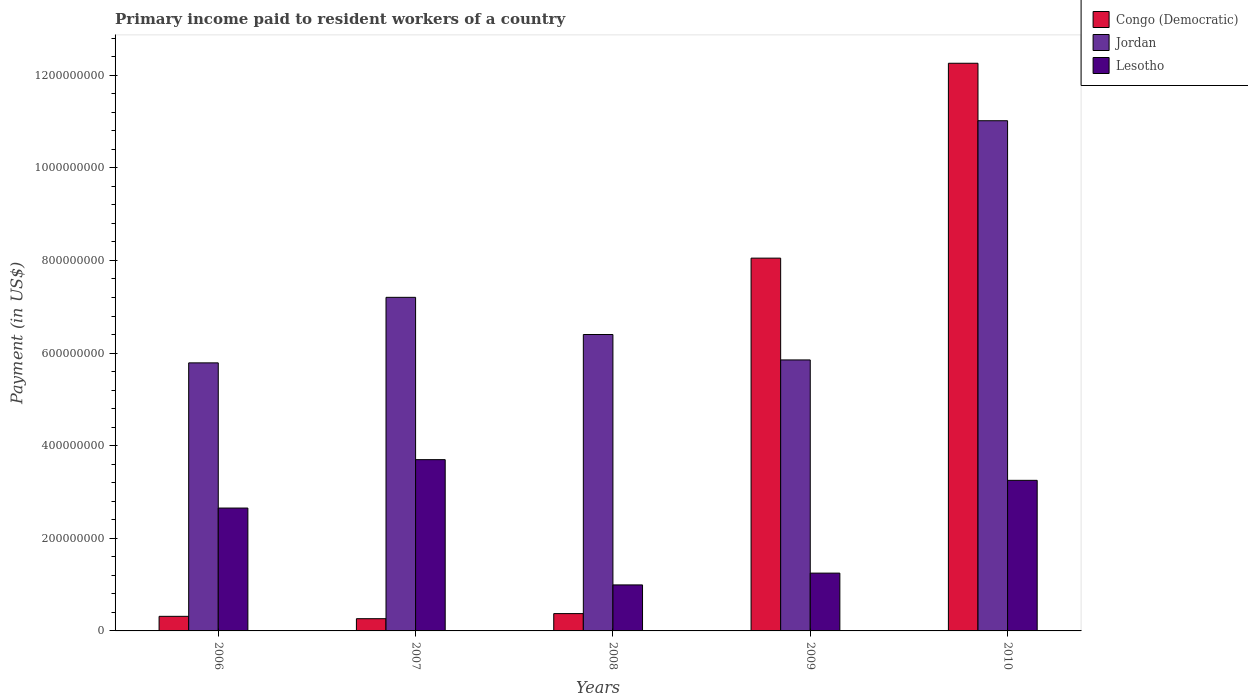How many groups of bars are there?
Your response must be concise. 5. Are the number of bars per tick equal to the number of legend labels?
Your response must be concise. Yes. Are the number of bars on each tick of the X-axis equal?
Provide a short and direct response. Yes. In how many cases, is the number of bars for a given year not equal to the number of legend labels?
Your answer should be very brief. 0. What is the amount paid to workers in Congo (Democratic) in 2007?
Offer a terse response. 2.64e+07. Across all years, what is the maximum amount paid to workers in Jordan?
Provide a succinct answer. 1.10e+09. Across all years, what is the minimum amount paid to workers in Jordan?
Ensure brevity in your answer.  5.79e+08. In which year was the amount paid to workers in Congo (Democratic) minimum?
Offer a very short reply. 2007. What is the total amount paid to workers in Congo (Democratic) in the graph?
Make the answer very short. 2.13e+09. What is the difference between the amount paid to workers in Jordan in 2008 and that in 2010?
Provide a short and direct response. -4.62e+08. What is the difference between the amount paid to workers in Lesotho in 2010 and the amount paid to workers in Jordan in 2006?
Your response must be concise. -2.54e+08. What is the average amount paid to workers in Lesotho per year?
Provide a succinct answer. 2.37e+08. In the year 2010, what is the difference between the amount paid to workers in Jordan and amount paid to workers in Congo (Democratic)?
Make the answer very short. -1.24e+08. In how many years, is the amount paid to workers in Jordan greater than 240000000 US$?
Give a very brief answer. 5. What is the ratio of the amount paid to workers in Jordan in 2007 to that in 2010?
Keep it short and to the point. 0.65. What is the difference between the highest and the second highest amount paid to workers in Congo (Democratic)?
Provide a short and direct response. 4.21e+08. What is the difference between the highest and the lowest amount paid to workers in Congo (Democratic)?
Provide a short and direct response. 1.20e+09. In how many years, is the amount paid to workers in Congo (Democratic) greater than the average amount paid to workers in Congo (Democratic) taken over all years?
Provide a short and direct response. 2. Is the sum of the amount paid to workers in Congo (Democratic) in 2006 and 2009 greater than the maximum amount paid to workers in Lesotho across all years?
Make the answer very short. Yes. What does the 1st bar from the left in 2009 represents?
Make the answer very short. Congo (Democratic). What does the 1st bar from the right in 2007 represents?
Your answer should be compact. Lesotho. Is it the case that in every year, the sum of the amount paid to workers in Congo (Democratic) and amount paid to workers in Lesotho is greater than the amount paid to workers in Jordan?
Ensure brevity in your answer.  No. How many bars are there?
Ensure brevity in your answer.  15. How many years are there in the graph?
Provide a succinct answer. 5. Does the graph contain any zero values?
Make the answer very short. No. Where does the legend appear in the graph?
Make the answer very short. Top right. What is the title of the graph?
Your answer should be compact. Primary income paid to resident workers of a country. Does "El Salvador" appear as one of the legend labels in the graph?
Give a very brief answer. No. What is the label or title of the Y-axis?
Your answer should be very brief. Payment (in US$). What is the Payment (in US$) in Congo (Democratic) in 2006?
Make the answer very short. 3.15e+07. What is the Payment (in US$) in Jordan in 2006?
Offer a very short reply. 5.79e+08. What is the Payment (in US$) in Lesotho in 2006?
Provide a short and direct response. 2.65e+08. What is the Payment (in US$) in Congo (Democratic) in 2007?
Provide a short and direct response. 2.64e+07. What is the Payment (in US$) of Jordan in 2007?
Your response must be concise. 7.20e+08. What is the Payment (in US$) in Lesotho in 2007?
Offer a terse response. 3.70e+08. What is the Payment (in US$) in Congo (Democratic) in 2008?
Make the answer very short. 3.74e+07. What is the Payment (in US$) of Jordan in 2008?
Give a very brief answer. 6.40e+08. What is the Payment (in US$) of Lesotho in 2008?
Offer a very short reply. 9.93e+07. What is the Payment (in US$) of Congo (Democratic) in 2009?
Your answer should be very brief. 8.05e+08. What is the Payment (in US$) of Jordan in 2009?
Make the answer very short. 5.85e+08. What is the Payment (in US$) of Lesotho in 2009?
Provide a short and direct response. 1.25e+08. What is the Payment (in US$) in Congo (Democratic) in 2010?
Your answer should be very brief. 1.23e+09. What is the Payment (in US$) of Jordan in 2010?
Offer a very short reply. 1.10e+09. What is the Payment (in US$) of Lesotho in 2010?
Offer a terse response. 3.25e+08. Across all years, what is the maximum Payment (in US$) in Congo (Democratic)?
Your answer should be very brief. 1.23e+09. Across all years, what is the maximum Payment (in US$) of Jordan?
Give a very brief answer. 1.10e+09. Across all years, what is the maximum Payment (in US$) of Lesotho?
Keep it short and to the point. 3.70e+08. Across all years, what is the minimum Payment (in US$) in Congo (Democratic)?
Provide a succinct answer. 2.64e+07. Across all years, what is the minimum Payment (in US$) in Jordan?
Provide a short and direct response. 5.79e+08. Across all years, what is the minimum Payment (in US$) in Lesotho?
Your answer should be compact. 9.93e+07. What is the total Payment (in US$) of Congo (Democratic) in the graph?
Offer a terse response. 2.13e+09. What is the total Payment (in US$) of Jordan in the graph?
Provide a succinct answer. 3.63e+09. What is the total Payment (in US$) of Lesotho in the graph?
Give a very brief answer. 1.18e+09. What is the difference between the Payment (in US$) of Congo (Democratic) in 2006 and that in 2007?
Offer a terse response. 5.10e+06. What is the difference between the Payment (in US$) of Jordan in 2006 and that in 2007?
Make the answer very short. -1.42e+08. What is the difference between the Payment (in US$) in Lesotho in 2006 and that in 2007?
Offer a terse response. -1.05e+08. What is the difference between the Payment (in US$) of Congo (Democratic) in 2006 and that in 2008?
Offer a terse response. -5.90e+06. What is the difference between the Payment (in US$) in Jordan in 2006 and that in 2008?
Ensure brevity in your answer.  -6.12e+07. What is the difference between the Payment (in US$) in Lesotho in 2006 and that in 2008?
Make the answer very short. 1.66e+08. What is the difference between the Payment (in US$) of Congo (Democratic) in 2006 and that in 2009?
Give a very brief answer. -7.74e+08. What is the difference between the Payment (in US$) of Jordan in 2006 and that in 2009?
Your response must be concise. -6.33e+06. What is the difference between the Payment (in US$) of Lesotho in 2006 and that in 2009?
Offer a very short reply. 1.40e+08. What is the difference between the Payment (in US$) in Congo (Democratic) in 2006 and that in 2010?
Make the answer very short. -1.19e+09. What is the difference between the Payment (in US$) in Jordan in 2006 and that in 2010?
Give a very brief answer. -5.23e+08. What is the difference between the Payment (in US$) in Lesotho in 2006 and that in 2010?
Offer a terse response. -5.99e+07. What is the difference between the Payment (in US$) of Congo (Democratic) in 2007 and that in 2008?
Offer a very short reply. -1.10e+07. What is the difference between the Payment (in US$) in Jordan in 2007 and that in 2008?
Give a very brief answer. 8.03e+07. What is the difference between the Payment (in US$) in Lesotho in 2007 and that in 2008?
Ensure brevity in your answer.  2.70e+08. What is the difference between the Payment (in US$) of Congo (Democratic) in 2007 and that in 2009?
Ensure brevity in your answer.  -7.79e+08. What is the difference between the Payment (in US$) of Jordan in 2007 and that in 2009?
Offer a very short reply. 1.35e+08. What is the difference between the Payment (in US$) of Lesotho in 2007 and that in 2009?
Your response must be concise. 2.45e+08. What is the difference between the Payment (in US$) in Congo (Democratic) in 2007 and that in 2010?
Offer a terse response. -1.20e+09. What is the difference between the Payment (in US$) of Jordan in 2007 and that in 2010?
Keep it short and to the point. -3.81e+08. What is the difference between the Payment (in US$) in Lesotho in 2007 and that in 2010?
Give a very brief answer. 4.47e+07. What is the difference between the Payment (in US$) in Congo (Democratic) in 2008 and that in 2009?
Your answer should be very brief. -7.68e+08. What is the difference between the Payment (in US$) of Jordan in 2008 and that in 2009?
Offer a terse response. 5.49e+07. What is the difference between the Payment (in US$) of Lesotho in 2008 and that in 2009?
Your answer should be compact. -2.55e+07. What is the difference between the Payment (in US$) of Congo (Democratic) in 2008 and that in 2010?
Provide a succinct answer. -1.19e+09. What is the difference between the Payment (in US$) of Jordan in 2008 and that in 2010?
Ensure brevity in your answer.  -4.62e+08. What is the difference between the Payment (in US$) of Lesotho in 2008 and that in 2010?
Offer a terse response. -2.26e+08. What is the difference between the Payment (in US$) of Congo (Democratic) in 2009 and that in 2010?
Offer a very short reply. -4.21e+08. What is the difference between the Payment (in US$) of Jordan in 2009 and that in 2010?
Your answer should be very brief. -5.17e+08. What is the difference between the Payment (in US$) of Lesotho in 2009 and that in 2010?
Your response must be concise. -2.00e+08. What is the difference between the Payment (in US$) of Congo (Democratic) in 2006 and the Payment (in US$) of Jordan in 2007?
Offer a terse response. -6.89e+08. What is the difference between the Payment (in US$) of Congo (Democratic) in 2006 and the Payment (in US$) of Lesotho in 2007?
Give a very brief answer. -3.38e+08. What is the difference between the Payment (in US$) of Jordan in 2006 and the Payment (in US$) of Lesotho in 2007?
Make the answer very short. 2.09e+08. What is the difference between the Payment (in US$) of Congo (Democratic) in 2006 and the Payment (in US$) of Jordan in 2008?
Make the answer very short. -6.09e+08. What is the difference between the Payment (in US$) of Congo (Democratic) in 2006 and the Payment (in US$) of Lesotho in 2008?
Make the answer very short. -6.78e+07. What is the difference between the Payment (in US$) of Jordan in 2006 and the Payment (in US$) of Lesotho in 2008?
Give a very brief answer. 4.79e+08. What is the difference between the Payment (in US$) in Congo (Democratic) in 2006 and the Payment (in US$) in Jordan in 2009?
Offer a terse response. -5.54e+08. What is the difference between the Payment (in US$) in Congo (Democratic) in 2006 and the Payment (in US$) in Lesotho in 2009?
Give a very brief answer. -9.33e+07. What is the difference between the Payment (in US$) in Jordan in 2006 and the Payment (in US$) in Lesotho in 2009?
Provide a succinct answer. 4.54e+08. What is the difference between the Payment (in US$) of Congo (Democratic) in 2006 and the Payment (in US$) of Jordan in 2010?
Ensure brevity in your answer.  -1.07e+09. What is the difference between the Payment (in US$) of Congo (Democratic) in 2006 and the Payment (in US$) of Lesotho in 2010?
Make the answer very short. -2.94e+08. What is the difference between the Payment (in US$) in Jordan in 2006 and the Payment (in US$) in Lesotho in 2010?
Offer a terse response. 2.54e+08. What is the difference between the Payment (in US$) of Congo (Democratic) in 2007 and the Payment (in US$) of Jordan in 2008?
Keep it short and to the point. -6.14e+08. What is the difference between the Payment (in US$) in Congo (Democratic) in 2007 and the Payment (in US$) in Lesotho in 2008?
Provide a short and direct response. -7.29e+07. What is the difference between the Payment (in US$) in Jordan in 2007 and the Payment (in US$) in Lesotho in 2008?
Keep it short and to the point. 6.21e+08. What is the difference between the Payment (in US$) of Congo (Democratic) in 2007 and the Payment (in US$) of Jordan in 2009?
Your answer should be compact. -5.59e+08. What is the difference between the Payment (in US$) of Congo (Democratic) in 2007 and the Payment (in US$) of Lesotho in 2009?
Your response must be concise. -9.84e+07. What is the difference between the Payment (in US$) in Jordan in 2007 and the Payment (in US$) in Lesotho in 2009?
Ensure brevity in your answer.  5.96e+08. What is the difference between the Payment (in US$) in Congo (Democratic) in 2007 and the Payment (in US$) in Jordan in 2010?
Offer a very short reply. -1.08e+09. What is the difference between the Payment (in US$) of Congo (Democratic) in 2007 and the Payment (in US$) of Lesotho in 2010?
Provide a short and direct response. -2.99e+08. What is the difference between the Payment (in US$) of Jordan in 2007 and the Payment (in US$) of Lesotho in 2010?
Offer a very short reply. 3.95e+08. What is the difference between the Payment (in US$) in Congo (Democratic) in 2008 and the Payment (in US$) in Jordan in 2009?
Your answer should be compact. -5.48e+08. What is the difference between the Payment (in US$) in Congo (Democratic) in 2008 and the Payment (in US$) in Lesotho in 2009?
Offer a very short reply. -8.74e+07. What is the difference between the Payment (in US$) of Jordan in 2008 and the Payment (in US$) of Lesotho in 2009?
Keep it short and to the point. 5.15e+08. What is the difference between the Payment (in US$) of Congo (Democratic) in 2008 and the Payment (in US$) of Jordan in 2010?
Keep it short and to the point. -1.06e+09. What is the difference between the Payment (in US$) of Congo (Democratic) in 2008 and the Payment (in US$) of Lesotho in 2010?
Your answer should be very brief. -2.88e+08. What is the difference between the Payment (in US$) in Jordan in 2008 and the Payment (in US$) in Lesotho in 2010?
Your answer should be compact. 3.15e+08. What is the difference between the Payment (in US$) of Congo (Democratic) in 2009 and the Payment (in US$) of Jordan in 2010?
Ensure brevity in your answer.  -2.97e+08. What is the difference between the Payment (in US$) in Congo (Democratic) in 2009 and the Payment (in US$) in Lesotho in 2010?
Offer a very short reply. 4.80e+08. What is the difference between the Payment (in US$) of Jordan in 2009 and the Payment (in US$) of Lesotho in 2010?
Keep it short and to the point. 2.60e+08. What is the average Payment (in US$) of Congo (Democratic) per year?
Keep it short and to the point. 4.25e+08. What is the average Payment (in US$) of Jordan per year?
Ensure brevity in your answer.  7.25e+08. What is the average Payment (in US$) in Lesotho per year?
Your response must be concise. 2.37e+08. In the year 2006, what is the difference between the Payment (in US$) in Congo (Democratic) and Payment (in US$) in Jordan?
Make the answer very short. -5.47e+08. In the year 2006, what is the difference between the Payment (in US$) of Congo (Democratic) and Payment (in US$) of Lesotho?
Give a very brief answer. -2.34e+08. In the year 2006, what is the difference between the Payment (in US$) of Jordan and Payment (in US$) of Lesotho?
Provide a short and direct response. 3.14e+08. In the year 2007, what is the difference between the Payment (in US$) of Congo (Democratic) and Payment (in US$) of Jordan?
Your response must be concise. -6.94e+08. In the year 2007, what is the difference between the Payment (in US$) of Congo (Democratic) and Payment (in US$) of Lesotho?
Your answer should be very brief. -3.43e+08. In the year 2007, what is the difference between the Payment (in US$) in Jordan and Payment (in US$) in Lesotho?
Give a very brief answer. 3.51e+08. In the year 2008, what is the difference between the Payment (in US$) of Congo (Democratic) and Payment (in US$) of Jordan?
Make the answer very short. -6.03e+08. In the year 2008, what is the difference between the Payment (in US$) in Congo (Democratic) and Payment (in US$) in Lesotho?
Make the answer very short. -6.19e+07. In the year 2008, what is the difference between the Payment (in US$) in Jordan and Payment (in US$) in Lesotho?
Keep it short and to the point. 5.41e+08. In the year 2009, what is the difference between the Payment (in US$) in Congo (Democratic) and Payment (in US$) in Jordan?
Your answer should be compact. 2.20e+08. In the year 2009, what is the difference between the Payment (in US$) of Congo (Democratic) and Payment (in US$) of Lesotho?
Your response must be concise. 6.80e+08. In the year 2009, what is the difference between the Payment (in US$) of Jordan and Payment (in US$) of Lesotho?
Your response must be concise. 4.60e+08. In the year 2010, what is the difference between the Payment (in US$) of Congo (Democratic) and Payment (in US$) of Jordan?
Make the answer very short. 1.24e+08. In the year 2010, what is the difference between the Payment (in US$) in Congo (Democratic) and Payment (in US$) in Lesotho?
Your answer should be compact. 9.01e+08. In the year 2010, what is the difference between the Payment (in US$) of Jordan and Payment (in US$) of Lesotho?
Your response must be concise. 7.77e+08. What is the ratio of the Payment (in US$) in Congo (Democratic) in 2006 to that in 2007?
Provide a short and direct response. 1.19. What is the ratio of the Payment (in US$) of Jordan in 2006 to that in 2007?
Offer a terse response. 0.8. What is the ratio of the Payment (in US$) of Lesotho in 2006 to that in 2007?
Offer a terse response. 0.72. What is the ratio of the Payment (in US$) in Congo (Democratic) in 2006 to that in 2008?
Keep it short and to the point. 0.84. What is the ratio of the Payment (in US$) of Jordan in 2006 to that in 2008?
Offer a terse response. 0.9. What is the ratio of the Payment (in US$) in Lesotho in 2006 to that in 2008?
Your response must be concise. 2.67. What is the ratio of the Payment (in US$) in Congo (Democratic) in 2006 to that in 2009?
Your response must be concise. 0.04. What is the ratio of the Payment (in US$) in Lesotho in 2006 to that in 2009?
Your answer should be very brief. 2.13. What is the ratio of the Payment (in US$) in Congo (Democratic) in 2006 to that in 2010?
Your response must be concise. 0.03. What is the ratio of the Payment (in US$) of Jordan in 2006 to that in 2010?
Your response must be concise. 0.53. What is the ratio of the Payment (in US$) of Lesotho in 2006 to that in 2010?
Offer a very short reply. 0.82. What is the ratio of the Payment (in US$) in Congo (Democratic) in 2007 to that in 2008?
Your answer should be compact. 0.71. What is the ratio of the Payment (in US$) in Jordan in 2007 to that in 2008?
Your answer should be very brief. 1.13. What is the ratio of the Payment (in US$) of Lesotho in 2007 to that in 2008?
Offer a very short reply. 3.72. What is the ratio of the Payment (in US$) in Congo (Democratic) in 2007 to that in 2009?
Offer a very short reply. 0.03. What is the ratio of the Payment (in US$) of Jordan in 2007 to that in 2009?
Ensure brevity in your answer.  1.23. What is the ratio of the Payment (in US$) in Lesotho in 2007 to that in 2009?
Your answer should be compact. 2.96. What is the ratio of the Payment (in US$) of Congo (Democratic) in 2007 to that in 2010?
Offer a terse response. 0.02. What is the ratio of the Payment (in US$) in Jordan in 2007 to that in 2010?
Keep it short and to the point. 0.65. What is the ratio of the Payment (in US$) of Lesotho in 2007 to that in 2010?
Provide a succinct answer. 1.14. What is the ratio of the Payment (in US$) in Congo (Democratic) in 2008 to that in 2009?
Ensure brevity in your answer.  0.05. What is the ratio of the Payment (in US$) of Jordan in 2008 to that in 2009?
Make the answer very short. 1.09. What is the ratio of the Payment (in US$) in Lesotho in 2008 to that in 2009?
Your answer should be compact. 0.8. What is the ratio of the Payment (in US$) in Congo (Democratic) in 2008 to that in 2010?
Provide a succinct answer. 0.03. What is the ratio of the Payment (in US$) of Jordan in 2008 to that in 2010?
Your answer should be compact. 0.58. What is the ratio of the Payment (in US$) of Lesotho in 2008 to that in 2010?
Give a very brief answer. 0.31. What is the ratio of the Payment (in US$) in Congo (Democratic) in 2009 to that in 2010?
Ensure brevity in your answer.  0.66. What is the ratio of the Payment (in US$) in Jordan in 2009 to that in 2010?
Your answer should be very brief. 0.53. What is the ratio of the Payment (in US$) of Lesotho in 2009 to that in 2010?
Your answer should be compact. 0.38. What is the difference between the highest and the second highest Payment (in US$) of Congo (Democratic)?
Provide a succinct answer. 4.21e+08. What is the difference between the highest and the second highest Payment (in US$) of Jordan?
Make the answer very short. 3.81e+08. What is the difference between the highest and the second highest Payment (in US$) of Lesotho?
Provide a short and direct response. 4.47e+07. What is the difference between the highest and the lowest Payment (in US$) in Congo (Democratic)?
Offer a very short reply. 1.20e+09. What is the difference between the highest and the lowest Payment (in US$) in Jordan?
Keep it short and to the point. 5.23e+08. What is the difference between the highest and the lowest Payment (in US$) in Lesotho?
Make the answer very short. 2.70e+08. 